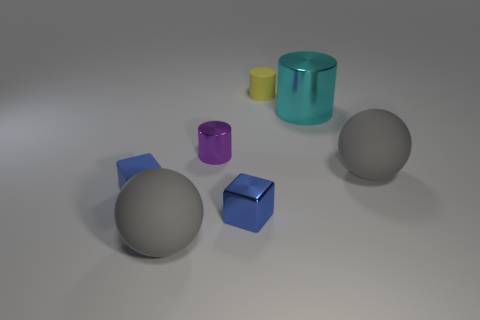What material is the blue object that is the same size as the shiny block? rubber 